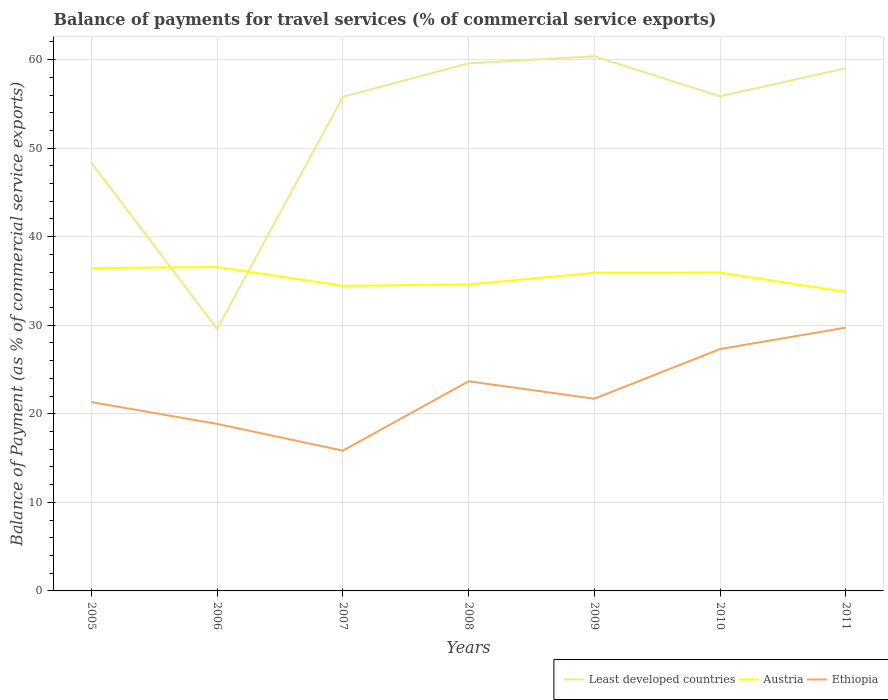Is the number of lines equal to the number of legend labels?
Make the answer very short. Yes. Across all years, what is the maximum balance of payments for travel services in Least developed countries?
Make the answer very short. 29.58. What is the total balance of payments for travel services in Least developed countries in the graph?
Provide a succinct answer. -3.17. What is the difference between the highest and the second highest balance of payments for travel services in Austria?
Your answer should be very brief. 2.81. How many lines are there?
Ensure brevity in your answer.  3. What is the difference between two consecutive major ticks on the Y-axis?
Give a very brief answer. 10. Where does the legend appear in the graph?
Ensure brevity in your answer.  Bottom right. How are the legend labels stacked?
Give a very brief answer. Horizontal. What is the title of the graph?
Make the answer very short. Balance of payments for travel services (% of commercial service exports). What is the label or title of the Y-axis?
Ensure brevity in your answer.  Balance of Payment (as % of commercial service exports). What is the Balance of Payment (as % of commercial service exports) of Least developed countries in 2005?
Your answer should be compact. 48.35. What is the Balance of Payment (as % of commercial service exports) in Austria in 2005?
Your answer should be very brief. 36.44. What is the Balance of Payment (as % of commercial service exports) of Ethiopia in 2005?
Offer a very short reply. 21.32. What is the Balance of Payment (as % of commercial service exports) in Least developed countries in 2006?
Your answer should be very brief. 29.58. What is the Balance of Payment (as % of commercial service exports) of Austria in 2006?
Provide a short and direct response. 36.58. What is the Balance of Payment (as % of commercial service exports) in Ethiopia in 2006?
Provide a succinct answer. 18.86. What is the Balance of Payment (as % of commercial service exports) of Least developed countries in 2007?
Give a very brief answer. 55.79. What is the Balance of Payment (as % of commercial service exports) of Austria in 2007?
Provide a short and direct response. 34.45. What is the Balance of Payment (as % of commercial service exports) of Ethiopia in 2007?
Keep it short and to the point. 15.84. What is the Balance of Payment (as % of commercial service exports) in Least developed countries in 2008?
Make the answer very short. 59.57. What is the Balance of Payment (as % of commercial service exports) in Austria in 2008?
Make the answer very short. 34.61. What is the Balance of Payment (as % of commercial service exports) in Ethiopia in 2008?
Offer a very short reply. 23.67. What is the Balance of Payment (as % of commercial service exports) in Least developed countries in 2009?
Keep it short and to the point. 60.37. What is the Balance of Payment (as % of commercial service exports) in Austria in 2009?
Your answer should be very brief. 35.92. What is the Balance of Payment (as % of commercial service exports) of Ethiopia in 2009?
Your answer should be compact. 21.71. What is the Balance of Payment (as % of commercial service exports) of Least developed countries in 2010?
Keep it short and to the point. 55.85. What is the Balance of Payment (as % of commercial service exports) of Austria in 2010?
Your response must be concise. 35.95. What is the Balance of Payment (as % of commercial service exports) of Ethiopia in 2010?
Give a very brief answer. 27.31. What is the Balance of Payment (as % of commercial service exports) of Least developed countries in 2011?
Give a very brief answer. 59.02. What is the Balance of Payment (as % of commercial service exports) of Austria in 2011?
Make the answer very short. 33.77. What is the Balance of Payment (as % of commercial service exports) in Ethiopia in 2011?
Offer a terse response. 29.73. Across all years, what is the maximum Balance of Payment (as % of commercial service exports) of Least developed countries?
Offer a terse response. 60.37. Across all years, what is the maximum Balance of Payment (as % of commercial service exports) of Austria?
Your answer should be compact. 36.58. Across all years, what is the maximum Balance of Payment (as % of commercial service exports) of Ethiopia?
Keep it short and to the point. 29.73. Across all years, what is the minimum Balance of Payment (as % of commercial service exports) in Least developed countries?
Provide a succinct answer. 29.58. Across all years, what is the minimum Balance of Payment (as % of commercial service exports) in Austria?
Your answer should be compact. 33.77. Across all years, what is the minimum Balance of Payment (as % of commercial service exports) in Ethiopia?
Offer a very short reply. 15.84. What is the total Balance of Payment (as % of commercial service exports) of Least developed countries in the graph?
Offer a terse response. 368.55. What is the total Balance of Payment (as % of commercial service exports) in Austria in the graph?
Offer a terse response. 247.73. What is the total Balance of Payment (as % of commercial service exports) in Ethiopia in the graph?
Provide a succinct answer. 158.45. What is the difference between the Balance of Payment (as % of commercial service exports) in Least developed countries in 2005 and that in 2006?
Your answer should be very brief. 18.77. What is the difference between the Balance of Payment (as % of commercial service exports) in Austria in 2005 and that in 2006?
Your response must be concise. -0.14. What is the difference between the Balance of Payment (as % of commercial service exports) in Ethiopia in 2005 and that in 2006?
Keep it short and to the point. 2.46. What is the difference between the Balance of Payment (as % of commercial service exports) of Least developed countries in 2005 and that in 2007?
Ensure brevity in your answer.  -7.44. What is the difference between the Balance of Payment (as % of commercial service exports) in Austria in 2005 and that in 2007?
Make the answer very short. 1.99. What is the difference between the Balance of Payment (as % of commercial service exports) in Ethiopia in 2005 and that in 2007?
Your answer should be compact. 5.48. What is the difference between the Balance of Payment (as % of commercial service exports) in Least developed countries in 2005 and that in 2008?
Provide a short and direct response. -11.22. What is the difference between the Balance of Payment (as % of commercial service exports) of Austria in 2005 and that in 2008?
Give a very brief answer. 1.83. What is the difference between the Balance of Payment (as % of commercial service exports) in Ethiopia in 2005 and that in 2008?
Offer a very short reply. -2.35. What is the difference between the Balance of Payment (as % of commercial service exports) in Least developed countries in 2005 and that in 2009?
Your answer should be very brief. -12.02. What is the difference between the Balance of Payment (as % of commercial service exports) in Austria in 2005 and that in 2009?
Ensure brevity in your answer.  0.52. What is the difference between the Balance of Payment (as % of commercial service exports) in Ethiopia in 2005 and that in 2009?
Your answer should be compact. -0.38. What is the difference between the Balance of Payment (as % of commercial service exports) of Least developed countries in 2005 and that in 2010?
Provide a succinct answer. -7.5. What is the difference between the Balance of Payment (as % of commercial service exports) in Austria in 2005 and that in 2010?
Provide a short and direct response. 0.49. What is the difference between the Balance of Payment (as % of commercial service exports) in Ethiopia in 2005 and that in 2010?
Ensure brevity in your answer.  -5.99. What is the difference between the Balance of Payment (as % of commercial service exports) in Least developed countries in 2005 and that in 2011?
Ensure brevity in your answer.  -10.67. What is the difference between the Balance of Payment (as % of commercial service exports) of Austria in 2005 and that in 2011?
Your response must be concise. 2.67. What is the difference between the Balance of Payment (as % of commercial service exports) in Ethiopia in 2005 and that in 2011?
Provide a succinct answer. -8.41. What is the difference between the Balance of Payment (as % of commercial service exports) of Least developed countries in 2006 and that in 2007?
Give a very brief answer. -26.21. What is the difference between the Balance of Payment (as % of commercial service exports) of Austria in 2006 and that in 2007?
Ensure brevity in your answer.  2.13. What is the difference between the Balance of Payment (as % of commercial service exports) of Ethiopia in 2006 and that in 2007?
Provide a short and direct response. 3.02. What is the difference between the Balance of Payment (as % of commercial service exports) of Least developed countries in 2006 and that in 2008?
Provide a short and direct response. -29.99. What is the difference between the Balance of Payment (as % of commercial service exports) of Austria in 2006 and that in 2008?
Offer a very short reply. 1.97. What is the difference between the Balance of Payment (as % of commercial service exports) in Ethiopia in 2006 and that in 2008?
Offer a very short reply. -4.81. What is the difference between the Balance of Payment (as % of commercial service exports) of Least developed countries in 2006 and that in 2009?
Your answer should be very brief. -30.79. What is the difference between the Balance of Payment (as % of commercial service exports) in Austria in 2006 and that in 2009?
Your answer should be very brief. 0.66. What is the difference between the Balance of Payment (as % of commercial service exports) of Ethiopia in 2006 and that in 2009?
Your answer should be very brief. -2.85. What is the difference between the Balance of Payment (as % of commercial service exports) in Least developed countries in 2006 and that in 2010?
Make the answer very short. -26.27. What is the difference between the Balance of Payment (as % of commercial service exports) of Austria in 2006 and that in 2010?
Make the answer very short. 0.63. What is the difference between the Balance of Payment (as % of commercial service exports) in Ethiopia in 2006 and that in 2010?
Your answer should be very brief. -8.45. What is the difference between the Balance of Payment (as % of commercial service exports) of Least developed countries in 2006 and that in 2011?
Provide a short and direct response. -29.44. What is the difference between the Balance of Payment (as % of commercial service exports) of Austria in 2006 and that in 2011?
Your answer should be compact. 2.81. What is the difference between the Balance of Payment (as % of commercial service exports) of Ethiopia in 2006 and that in 2011?
Offer a very short reply. -10.87. What is the difference between the Balance of Payment (as % of commercial service exports) in Least developed countries in 2007 and that in 2008?
Give a very brief answer. -3.78. What is the difference between the Balance of Payment (as % of commercial service exports) of Austria in 2007 and that in 2008?
Your answer should be compact. -0.16. What is the difference between the Balance of Payment (as % of commercial service exports) in Ethiopia in 2007 and that in 2008?
Your answer should be very brief. -7.83. What is the difference between the Balance of Payment (as % of commercial service exports) of Least developed countries in 2007 and that in 2009?
Your response must be concise. -4.58. What is the difference between the Balance of Payment (as % of commercial service exports) of Austria in 2007 and that in 2009?
Make the answer very short. -1.47. What is the difference between the Balance of Payment (as % of commercial service exports) in Ethiopia in 2007 and that in 2009?
Ensure brevity in your answer.  -5.87. What is the difference between the Balance of Payment (as % of commercial service exports) of Least developed countries in 2007 and that in 2010?
Provide a short and direct response. -0.06. What is the difference between the Balance of Payment (as % of commercial service exports) in Austria in 2007 and that in 2010?
Keep it short and to the point. -1.5. What is the difference between the Balance of Payment (as % of commercial service exports) of Ethiopia in 2007 and that in 2010?
Provide a succinct answer. -11.47. What is the difference between the Balance of Payment (as % of commercial service exports) in Least developed countries in 2007 and that in 2011?
Give a very brief answer. -3.23. What is the difference between the Balance of Payment (as % of commercial service exports) of Austria in 2007 and that in 2011?
Make the answer very short. 0.68. What is the difference between the Balance of Payment (as % of commercial service exports) of Ethiopia in 2007 and that in 2011?
Provide a succinct answer. -13.89. What is the difference between the Balance of Payment (as % of commercial service exports) in Least developed countries in 2008 and that in 2009?
Provide a short and direct response. -0.8. What is the difference between the Balance of Payment (as % of commercial service exports) of Austria in 2008 and that in 2009?
Your answer should be very brief. -1.31. What is the difference between the Balance of Payment (as % of commercial service exports) of Ethiopia in 2008 and that in 2009?
Your answer should be compact. 1.97. What is the difference between the Balance of Payment (as % of commercial service exports) of Least developed countries in 2008 and that in 2010?
Provide a succinct answer. 3.72. What is the difference between the Balance of Payment (as % of commercial service exports) in Austria in 2008 and that in 2010?
Your answer should be very brief. -1.33. What is the difference between the Balance of Payment (as % of commercial service exports) in Ethiopia in 2008 and that in 2010?
Offer a terse response. -3.64. What is the difference between the Balance of Payment (as % of commercial service exports) of Least developed countries in 2008 and that in 2011?
Your answer should be compact. 0.55. What is the difference between the Balance of Payment (as % of commercial service exports) in Austria in 2008 and that in 2011?
Your response must be concise. 0.84. What is the difference between the Balance of Payment (as % of commercial service exports) in Ethiopia in 2008 and that in 2011?
Provide a short and direct response. -6.06. What is the difference between the Balance of Payment (as % of commercial service exports) of Least developed countries in 2009 and that in 2010?
Make the answer very short. 4.52. What is the difference between the Balance of Payment (as % of commercial service exports) of Austria in 2009 and that in 2010?
Your answer should be very brief. -0.03. What is the difference between the Balance of Payment (as % of commercial service exports) in Ethiopia in 2009 and that in 2010?
Offer a terse response. -5.61. What is the difference between the Balance of Payment (as % of commercial service exports) of Least developed countries in 2009 and that in 2011?
Offer a terse response. 1.35. What is the difference between the Balance of Payment (as % of commercial service exports) of Austria in 2009 and that in 2011?
Offer a terse response. 2.15. What is the difference between the Balance of Payment (as % of commercial service exports) in Ethiopia in 2009 and that in 2011?
Make the answer very short. -8.03. What is the difference between the Balance of Payment (as % of commercial service exports) of Least developed countries in 2010 and that in 2011?
Your answer should be compact. -3.17. What is the difference between the Balance of Payment (as % of commercial service exports) in Austria in 2010 and that in 2011?
Your response must be concise. 2.18. What is the difference between the Balance of Payment (as % of commercial service exports) in Ethiopia in 2010 and that in 2011?
Ensure brevity in your answer.  -2.42. What is the difference between the Balance of Payment (as % of commercial service exports) of Least developed countries in 2005 and the Balance of Payment (as % of commercial service exports) of Austria in 2006?
Give a very brief answer. 11.77. What is the difference between the Balance of Payment (as % of commercial service exports) of Least developed countries in 2005 and the Balance of Payment (as % of commercial service exports) of Ethiopia in 2006?
Give a very brief answer. 29.49. What is the difference between the Balance of Payment (as % of commercial service exports) of Austria in 2005 and the Balance of Payment (as % of commercial service exports) of Ethiopia in 2006?
Make the answer very short. 17.58. What is the difference between the Balance of Payment (as % of commercial service exports) in Least developed countries in 2005 and the Balance of Payment (as % of commercial service exports) in Austria in 2007?
Your answer should be compact. 13.9. What is the difference between the Balance of Payment (as % of commercial service exports) in Least developed countries in 2005 and the Balance of Payment (as % of commercial service exports) in Ethiopia in 2007?
Offer a terse response. 32.51. What is the difference between the Balance of Payment (as % of commercial service exports) in Austria in 2005 and the Balance of Payment (as % of commercial service exports) in Ethiopia in 2007?
Keep it short and to the point. 20.6. What is the difference between the Balance of Payment (as % of commercial service exports) of Least developed countries in 2005 and the Balance of Payment (as % of commercial service exports) of Austria in 2008?
Offer a very short reply. 13.74. What is the difference between the Balance of Payment (as % of commercial service exports) of Least developed countries in 2005 and the Balance of Payment (as % of commercial service exports) of Ethiopia in 2008?
Give a very brief answer. 24.68. What is the difference between the Balance of Payment (as % of commercial service exports) in Austria in 2005 and the Balance of Payment (as % of commercial service exports) in Ethiopia in 2008?
Ensure brevity in your answer.  12.77. What is the difference between the Balance of Payment (as % of commercial service exports) of Least developed countries in 2005 and the Balance of Payment (as % of commercial service exports) of Austria in 2009?
Give a very brief answer. 12.43. What is the difference between the Balance of Payment (as % of commercial service exports) of Least developed countries in 2005 and the Balance of Payment (as % of commercial service exports) of Ethiopia in 2009?
Your answer should be very brief. 26.65. What is the difference between the Balance of Payment (as % of commercial service exports) of Austria in 2005 and the Balance of Payment (as % of commercial service exports) of Ethiopia in 2009?
Provide a short and direct response. 14.74. What is the difference between the Balance of Payment (as % of commercial service exports) in Least developed countries in 2005 and the Balance of Payment (as % of commercial service exports) in Austria in 2010?
Your answer should be compact. 12.4. What is the difference between the Balance of Payment (as % of commercial service exports) of Least developed countries in 2005 and the Balance of Payment (as % of commercial service exports) of Ethiopia in 2010?
Your answer should be very brief. 21.04. What is the difference between the Balance of Payment (as % of commercial service exports) in Austria in 2005 and the Balance of Payment (as % of commercial service exports) in Ethiopia in 2010?
Provide a succinct answer. 9.13. What is the difference between the Balance of Payment (as % of commercial service exports) of Least developed countries in 2005 and the Balance of Payment (as % of commercial service exports) of Austria in 2011?
Provide a succinct answer. 14.58. What is the difference between the Balance of Payment (as % of commercial service exports) in Least developed countries in 2005 and the Balance of Payment (as % of commercial service exports) in Ethiopia in 2011?
Give a very brief answer. 18.62. What is the difference between the Balance of Payment (as % of commercial service exports) of Austria in 2005 and the Balance of Payment (as % of commercial service exports) of Ethiopia in 2011?
Give a very brief answer. 6.71. What is the difference between the Balance of Payment (as % of commercial service exports) in Least developed countries in 2006 and the Balance of Payment (as % of commercial service exports) in Austria in 2007?
Make the answer very short. -4.87. What is the difference between the Balance of Payment (as % of commercial service exports) of Least developed countries in 2006 and the Balance of Payment (as % of commercial service exports) of Ethiopia in 2007?
Your answer should be very brief. 13.74. What is the difference between the Balance of Payment (as % of commercial service exports) in Austria in 2006 and the Balance of Payment (as % of commercial service exports) in Ethiopia in 2007?
Your answer should be very brief. 20.74. What is the difference between the Balance of Payment (as % of commercial service exports) of Least developed countries in 2006 and the Balance of Payment (as % of commercial service exports) of Austria in 2008?
Make the answer very short. -5.03. What is the difference between the Balance of Payment (as % of commercial service exports) of Least developed countries in 2006 and the Balance of Payment (as % of commercial service exports) of Ethiopia in 2008?
Give a very brief answer. 5.91. What is the difference between the Balance of Payment (as % of commercial service exports) of Austria in 2006 and the Balance of Payment (as % of commercial service exports) of Ethiopia in 2008?
Ensure brevity in your answer.  12.91. What is the difference between the Balance of Payment (as % of commercial service exports) in Least developed countries in 2006 and the Balance of Payment (as % of commercial service exports) in Austria in 2009?
Give a very brief answer. -6.34. What is the difference between the Balance of Payment (as % of commercial service exports) in Least developed countries in 2006 and the Balance of Payment (as % of commercial service exports) in Ethiopia in 2009?
Your response must be concise. 7.87. What is the difference between the Balance of Payment (as % of commercial service exports) of Austria in 2006 and the Balance of Payment (as % of commercial service exports) of Ethiopia in 2009?
Ensure brevity in your answer.  14.87. What is the difference between the Balance of Payment (as % of commercial service exports) in Least developed countries in 2006 and the Balance of Payment (as % of commercial service exports) in Austria in 2010?
Your response must be concise. -6.37. What is the difference between the Balance of Payment (as % of commercial service exports) of Least developed countries in 2006 and the Balance of Payment (as % of commercial service exports) of Ethiopia in 2010?
Give a very brief answer. 2.27. What is the difference between the Balance of Payment (as % of commercial service exports) in Austria in 2006 and the Balance of Payment (as % of commercial service exports) in Ethiopia in 2010?
Provide a short and direct response. 9.27. What is the difference between the Balance of Payment (as % of commercial service exports) of Least developed countries in 2006 and the Balance of Payment (as % of commercial service exports) of Austria in 2011?
Offer a terse response. -4.19. What is the difference between the Balance of Payment (as % of commercial service exports) of Least developed countries in 2006 and the Balance of Payment (as % of commercial service exports) of Ethiopia in 2011?
Provide a succinct answer. -0.15. What is the difference between the Balance of Payment (as % of commercial service exports) in Austria in 2006 and the Balance of Payment (as % of commercial service exports) in Ethiopia in 2011?
Your answer should be very brief. 6.85. What is the difference between the Balance of Payment (as % of commercial service exports) in Least developed countries in 2007 and the Balance of Payment (as % of commercial service exports) in Austria in 2008?
Your answer should be very brief. 21.18. What is the difference between the Balance of Payment (as % of commercial service exports) of Least developed countries in 2007 and the Balance of Payment (as % of commercial service exports) of Ethiopia in 2008?
Keep it short and to the point. 32.12. What is the difference between the Balance of Payment (as % of commercial service exports) of Austria in 2007 and the Balance of Payment (as % of commercial service exports) of Ethiopia in 2008?
Offer a very short reply. 10.78. What is the difference between the Balance of Payment (as % of commercial service exports) of Least developed countries in 2007 and the Balance of Payment (as % of commercial service exports) of Austria in 2009?
Keep it short and to the point. 19.87. What is the difference between the Balance of Payment (as % of commercial service exports) of Least developed countries in 2007 and the Balance of Payment (as % of commercial service exports) of Ethiopia in 2009?
Ensure brevity in your answer.  34.09. What is the difference between the Balance of Payment (as % of commercial service exports) of Austria in 2007 and the Balance of Payment (as % of commercial service exports) of Ethiopia in 2009?
Your response must be concise. 12.74. What is the difference between the Balance of Payment (as % of commercial service exports) in Least developed countries in 2007 and the Balance of Payment (as % of commercial service exports) in Austria in 2010?
Give a very brief answer. 19.84. What is the difference between the Balance of Payment (as % of commercial service exports) of Least developed countries in 2007 and the Balance of Payment (as % of commercial service exports) of Ethiopia in 2010?
Your answer should be very brief. 28.48. What is the difference between the Balance of Payment (as % of commercial service exports) in Austria in 2007 and the Balance of Payment (as % of commercial service exports) in Ethiopia in 2010?
Offer a terse response. 7.14. What is the difference between the Balance of Payment (as % of commercial service exports) in Least developed countries in 2007 and the Balance of Payment (as % of commercial service exports) in Austria in 2011?
Ensure brevity in your answer.  22.02. What is the difference between the Balance of Payment (as % of commercial service exports) in Least developed countries in 2007 and the Balance of Payment (as % of commercial service exports) in Ethiopia in 2011?
Provide a short and direct response. 26.06. What is the difference between the Balance of Payment (as % of commercial service exports) of Austria in 2007 and the Balance of Payment (as % of commercial service exports) of Ethiopia in 2011?
Give a very brief answer. 4.72. What is the difference between the Balance of Payment (as % of commercial service exports) of Least developed countries in 2008 and the Balance of Payment (as % of commercial service exports) of Austria in 2009?
Keep it short and to the point. 23.65. What is the difference between the Balance of Payment (as % of commercial service exports) in Least developed countries in 2008 and the Balance of Payment (as % of commercial service exports) in Ethiopia in 2009?
Your answer should be very brief. 37.87. What is the difference between the Balance of Payment (as % of commercial service exports) in Austria in 2008 and the Balance of Payment (as % of commercial service exports) in Ethiopia in 2009?
Offer a terse response. 12.91. What is the difference between the Balance of Payment (as % of commercial service exports) of Least developed countries in 2008 and the Balance of Payment (as % of commercial service exports) of Austria in 2010?
Ensure brevity in your answer.  23.63. What is the difference between the Balance of Payment (as % of commercial service exports) of Least developed countries in 2008 and the Balance of Payment (as % of commercial service exports) of Ethiopia in 2010?
Give a very brief answer. 32.26. What is the difference between the Balance of Payment (as % of commercial service exports) in Austria in 2008 and the Balance of Payment (as % of commercial service exports) in Ethiopia in 2010?
Your answer should be compact. 7.3. What is the difference between the Balance of Payment (as % of commercial service exports) of Least developed countries in 2008 and the Balance of Payment (as % of commercial service exports) of Austria in 2011?
Offer a terse response. 25.8. What is the difference between the Balance of Payment (as % of commercial service exports) of Least developed countries in 2008 and the Balance of Payment (as % of commercial service exports) of Ethiopia in 2011?
Ensure brevity in your answer.  29.84. What is the difference between the Balance of Payment (as % of commercial service exports) of Austria in 2008 and the Balance of Payment (as % of commercial service exports) of Ethiopia in 2011?
Offer a terse response. 4.88. What is the difference between the Balance of Payment (as % of commercial service exports) of Least developed countries in 2009 and the Balance of Payment (as % of commercial service exports) of Austria in 2010?
Make the answer very short. 24.42. What is the difference between the Balance of Payment (as % of commercial service exports) of Least developed countries in 2009 and the Balance of Payment (as % of commercial service exports) of Ethiopia in 2010?
Keep it short and to the point. 33.06. What is the difference between the Balance of Payment (as % of commercial service exports) in Austria in 2009 and the Balance of Payment (as % of commercial service exports) in Ethiopia in 2010?
Give a very brief answer. 8.61. What is the difference between the Balance of Payment (as % of commercial service exports) in Least developed countries in 2009 and the Balance of Payment (as % of commercial service exports) in Austria in 2011?
Ensure brevity in your answer.  26.6. What is the difference between the Balance of Payment (as % of commercial service exports) of Least developed countries in 2009 and the Balance of Payment (as % of commercial service exports) of Ethiopia in 2011?
Give a very brief answer. 30.64. What is the difference between the Balance of Payment (as % of commercial service exports) of Austria in 2009 and the Balance of Payment (as % of commercial service exports) of Ethiopia in 2011?
Provide a succinct answer. 6.19. What is the difference between the Balance of Payment (as % of commercial service exports) in Least developed countries in 2010 and the Balance of Payment (as % of commercial service exports) in Austria in 2011?
Keep it short and to the point. 22.08. What is the difference between the Balance of Payment (as % of commercial service exports) in Least developed countries in 2010 and the Balance of Payment (as % of commercial service exports) in Ethiopia in 2011?
Offer a very short reply. 26.12. What is the difference between the Balance of Payment (as % of commercial service exports) of Austria in 2010 and the Balance of Payment (as % of commercial service exports) of Ethiopia in 2011?
Keep it short and to the point. 6.22. What is the average Balance of Payment (as % of commercial service exports) of Least developed countries per year?
Your response must be concise. 52.65. What is the average Balance of Payment (as % of commercial service exports) in Austria per year?
Offer a terse response. 35.39. What is the average Balance of Payment (as % of commercial service exports) of Ethiopia per year?
Your answer should be very brief. 22.64. In the year 2005, what is the difference between the Balance of Payment (as % of commercial service exports) in Least developed countries and Balance of Payment (as % of commercial service exports) in Austria?
Offer a very short reply. 11.91. In the year 2005, what is the difference between the Balance of Payment (as % of commercial service exports) in Least developed countries and Balance of Payment (as % of commercial service exports) in Ethiopia?
Provide a succinct answer. 27.03. In the year 2005, what is the difference between the Balance of Payment (as % of commercial service exports) of Austria and Balance of Payment (as % of commercial service exports) of Ethiopia?
Ensure brevity in your answer.  15.12. In the year 2006, what is the difference between the Balance of Payment (as % of commercial service exports) in Least developed countries and Balance of Payment (as % of commercial service exports) in Austria?
Give a very brief answer. -7. In the year 2006, what is the difference between the Balance of Payment (as % of commercial service exports) of Least developed countries and Balance of Payment (as % of commercial service exports) of Ethiopia?
Provide a short and direct response. 10.72. In the year 2006, what is the difference between the Balance of Payment (as % of commercial service exports) of Austria and Balance of Payment (as % of commercial service exports) of Ethiopia?
Give a very brief answer. 17.72. In the year 2007, what is the difference between the Balance of Payment (as % of commercial service exports) in Least developed countries and Balance of Payment (as % of commercial service exports) in Austria?
Offer a very short reply. 21.34. In the year 2007, what is the difference between the Balance of Payment (as % of commercial service exports) in Least developed countries and Balance of Payment (as % of commercial service exports) in Ethiopia?
Your response must be concise. 39.95. In the year 2007, what is the difference between the Balance of Payment (as % of commercial service exports) of Austria and Balance of Payment (as % of commercial service exports) of Ethiopia?
Give a very brief answer. 18.61. In the year 2008, what is the difference between the Balance of Payment (as % of commercial service exports) of Least developed countries and Balance of Payment (as % of commercial service exports) of Austria?
Offer a very short reply. 24.96. In the year 2008, what is the difference between the Balance of Payment (as % of commercial service exports) in Least developed countries and Balance of Payment (as % of commercial service exports) in Ethiopia?
Provide a short and direct response. 35.9. In the year 2008, what is the difference between the Balance of Payment (as % of commercial service exports) in Austria and Balance of Payment (as % of commercial service exports) in Ethiopia?
Provide a succinct answer. 10.94. In the year 2009, what is the difference between the Balance of Payment (as % of commercial service exports) of Least developed countries and Balance of Payment (as % of commercial service exports) of Austria?
Provide a short and direct response. 24.45. In the year 2009, what is the difference between the Balance of Payment (as % of commercial service exports) in Least developed countries and Balance of Payment (as % of commercial service exports) in Ethiopia?
Keep it short and to the point. 38.67. In the year 2009, what is the difference between the Balance of Payment (as % of commercial service exports) in Austria and Balance of Payment (as % of commercial service exports) in Ethiopia?
Offer a terse response. 14.22. In the year 2010, what is the difference between the Balance of Payment (as % of commercial service exports) in Least developed countries and Balance of Payment (as % of commercial service exports) in Austria?
Provide a succinct answer. 19.9. In the year 2010, what is the difference between the Balance of Payment (as % of commercial service exports) of Least developed countries and Balance of Payment (as % of commercial service exports) of Ethiopia?
Offer a very short reply. 28.54. In the year 2010, what is the difference between the Balance of Payment (as % of commercial service exports) of Austria and Balance of Payment (as % of commercial service exports) of Ethiopia?
Offer a terse response. 8.64. In the year 2011, what is the difference between the Balance of Payment (as % of commercial service exports) in Least developed countries and Balance of Payment (as % of commercial service exports) in Austria?
Give a very brief answer. 25.25. In the year 2011, what is the difference between the Balance of Payment (as % of commercial service exports) of Least developed countries and Balance of Payment (as % of commercial service exports) of Ethiopia?
Give a very brief answer. 29.29. In the year 2011, what is the difference between the Balance of Payment (as % of commercial service exports) in Austria and Balance of Payment (as % of commercial service exports) in Ethiopia?
Your answer should be very brief. 4.04. What is the ratio of the Balance of Payment (as % of commercial service exports) in Least developed countries in 2005 to that in 2006?
Your response must be concise. 1.63. What is the ratio of the Balance of Payment (as % of commercial service exports) in Austria in 2005 to that in 2006?
Your answer should be very brief. 1. What is the ratio of the Balance of Payment (as % of commercial service exports) in Ethiopia in 2005 to that in 2006?
Give a very brief answer. 1.13. What is the ratio of the Balance of Payment (as % of commercial service exports) in Least developed countries in 2005 to that in 2007?
Your answer should be very brief. 0.87. What is the ratio of the Balance of Payment (as % of commercial service exports) in Austria in 2005 to that in 2007?
Provide a short and direct response. 1.06. What is the ratio of the Balance of Payment (as % of commercial service exports) in Ethiopia in 2005 to that in 2007?
Give a very brief answer. 1.35. What is the ratio of the Balance of Payment (as % of commercial service exports) in Least developed countries in 2005 to that in 2008?
Your answer should be very brief. 0.81. What is the ratio of the Balance of Payment (as % of commercial service exports) of Austria in 2005 to that in 2008?
Give a very brief answer. 1.05. What is the ratio of the Balance of Payment (as % of commercial service exports) in Ethiopia in 2005 to that in 2008?
Offer a terse response. 0.9. What is the ratio of the Balance of Payment (as % of commercial service exports) of Least developed countries in 2005 to that in 2009?
Your response must be concise. 0.8. What is the ratio of the Balance of Payment (as % of commercial service exports) of Austria in 2005 to that in 2009?
Provide a succinct answer. 1.01. What is the ratio of the Balance of Payment (as % of commercial service exports) of Ethiopia in 2005 to that in 2009?
Provide a succinct answer. 0.98. What is the ratio of the Balance of Payment (as % of commercial service exports) of Least developed countries in 2005 to that in 2010?
Keep it short and to the point. 0.87. What is the ratio of the Balance of Payment (as % of commercial service exports) in Austria in 2005 to that in 2010?
Ensure brevity in your answer.  1.01. What is the ratio of the Balance of Payment (as % of commercial service exports) in Ethiopia in 2005 to that in 2010?
Keep it short and to the point. 0.78. What is the ratio of the Balance of Payment (as % of commercial service exports) in Least developed countries in 2005 to that in 2011?
Your answer should be compact. 0.82. What is the ratio of the Balance of Payment (as % of commercial service exports) of Austria in 2005 to that in 2011?
Provide a succinct answer. 1.08. What is the ratio of the Balance of Payment (as % of commercial service exports) in Ethiopia in 2005 to that in 2011?
Provide a short and direct response. 0.72. What is the ratio of the Balance of Payment (as % of commercial service exports) in Least developed countries in 2006 to that in 2007?
Ensure brevity in your answer.  0.53. What is the ratio of the Balance of Payment (as % of commercial service exports) of Austria in 2006 to that in 2007?
Your answer should be very brief. 1.06. What is the ratio of the Balance of Payment (as % of commercial service exports) of Ethiopia in 2006 to that in 2007?
Your answer should be very brief. 1.19. What is the ratio of the Balance of Payment (as % of commercial service exports) of Least developed countries in 2006 to that in 2008?
Your answer should be very brief. 0.5. What is the ratio of the Balance of Payment (as % of commercial service exports) of Austria in 2006 to that in 2008?
Give a very brief answer. 1.06. What is the ratio of the Balance of Payment (as % of commercial service exports) of Ethiopia in 2006 to that in 2008?
Your answer should be compact. 0.8. What is the ratio of the Balance of Payment (as % of commercial service exports) of Least developed countries in 2006 to that in 2009?
Provide a short and direct response. 0.49. What is the ratio of the Balance of Payment (as % of commercial service exports) of Austria in 2006 to that in 2009?
Your answer should be very brief. 1.02. What is the ratio of the Balance of Payment (as % of commercial service exports) in Ethiopia in 2006 to that in 2009?
Offer a terse response. 0.87. What is the ratio of the Balance of Payment (as % of commercial service exports) in Least developed countries in 2006 to that in 2010?
Your answer should be compact. 0.53. What is the ratio of the Balance of Payment (as % of commercial service exports) of Austria in 2006 to that in 2010?
Your response must be concise. 1.02. What is the ratio of the Balance of Payment (as % of commercial service exports) of Ethiopia in 2006 to that in 2010?
Your response must be concise. 0.69. What is the ratio of the Balance of Payment (as % of commercial service exports) in Least developed countries in 2006 to that in 2011?
Offer a very short reply. 0.5. What is the ratio of the Balance of Payment (as % of commercial service exports) of Austria in 2006 to that in 2011?
Your answer should be compact. 1.08. What is the ratio of the Balance of Payment (as % of commercial service exports) of Ethiopia in 2006 to that in 2011?
Make the answer very short. 0.63. What is the ratio of the Balance of Payment (as % of commercial service exports) in Least developed countries in 2007 to that in 2008?
Your answer should be compact. 0.94. What is the ratio of the Balance of Payment (as % of commercial service exports) of Ethiopia in 2007 to that in 2008?
Make the answer very short. 0.67. What is the ratio of the Balance of Payment (as % of commercial service exports) of Least developed countries in 2007 to that in 2009?
Your response must be concise. 0.92. What is the ratio of the Balance of Payment (as % of commercial service exports) in Ethiopia in 2007 to that in 2009?
Your answer should be compact. 0.73. What is the ratio of the Balance of Payment (as % of commercial service exports) of Ethiopia in 2007 to that in 2010?
Your answer should be very brief. 0.58. What is the ratio of the Balance of Payment (as % of commercial service exports) in Least developed countries in 2007 to that in 2011?
Your response must be concise. 0.95. What is the ratio of the Balance of Payment (as % of commercial service exports) of Austria in 2007 to that in 2011?
Offer a very short reply. 1.02. What is the ratio of the Balance of Payment (as % of commercial service exports) in Ethiopia in 2007 to that in 2011?
Keep it short and to the point. 0.53. What is the ratio of the Balance of Payment (as % of commercial service exports) of Austria in 2008 to that in 2009?
Keep it short and to the point. 0.96. What is the ratio of the Balance of Payment (as % of commercial service exports) of Ethiopia in 2008 to that in 2009?
Provide a succinct answer. 1.09. What is the ratio of the Balance of Payment (as % of commercial service exports) in Least developed countries in 2008 to that in 2010?
Keep it short and to the point. 1.07. What is the ratio of the Balance of Payment (as % of commercial service exports) of Austria in 2008 to that in 2010?
Provide a short and direct response. 0.96. What is the ratio of the Balance of Payment (as % of commercial service exports) of Ethiopia in 2008 to that in 2010?
Provide a succinct answer. 0.87. What is the ratio of the Balance of Payment (as % of commercial service exports) of Least developed countries in 2008 to that in 2011?
Provide a succinct answer. 1.01. What is the ratio of the Balance of Payment (as % of commercial service exports) in Ethiopia in 2008 to that in 2011?
Provide a succinct answer. 0.8. What is the ratio of the Balance of Payment (as % of commercial service exports) in Least developed countries in 2009 to that in 2010?
Your answer should be compact. 1.08. What is the ratio of the Balance of Payment (as % of commercial service exports) of Austria in 2009 to that in 2010?
Your response must be concise. 1. What is the ratio of the Balance of Payment (as % of commercial service exports) of Ethiopia in 2009 to that in 2010?
Provide a succinct answer. 0.79. What is the ratio of the Balance of Payment (as % of commercial service exports) in Least developed countries in 2009 to that in 2011?
Make the answer very short. 1.02. What is the ratio of the Balance of Payment (as % of commercial service exports) of Austria in 2009 to that in 2011?
Your answer should be very brief. 1.06. What is the ratio of the Balance of Payment (as % of commercial service exports) of Ethiopia in 2009 to that in 2011?
Offer a very short reply. 0.73. What is the ratio of the Balance of Payment (as % of commercial service exports) of Least developed countries in 2010 to that in 2011?
Offer a very short reply. 0.95. What is the ratio of the Balance of Payment (as % of commercial service exports) of Austria in 2010 to that in 2011?
Make the answer very short. 1.06. What is the ratio of the Balance of Payment (as % of commercial service exports) of Ethiopia in 2010 to that in 2011?
Make the answer very short. 0.92. What is the difference between the highest and the second highest Balance of Payment (as % of commercial service exports) of Least developed countries?
Keep it short and to the point. 0.8. What is the difference between the highest and the second highest Balance of Payment (as % of commercial service exports) of Austria?
Ensure brevity in your answer.  0.14. What is the difference between the highest and the second highest Balance of Payment (as % of commercial service exports) in Ethiopia?
Your response must be concise. 2.42. What is the difference between the highest and the lowest Balance of Payment (as % of commercial service exports) of Least developed countries?
Give a very brief answer. 30.79. What is the difference between the highest and the lowest Balance of Payment (as % of commercial service exports) in Austria?
Your answer should be very brief. 2.81. What is the difference between the highest and the lowest Balance of Payment (as % of commercial service exports) of Ethiopia?
Ensure brevity in your answer.  13.89. 